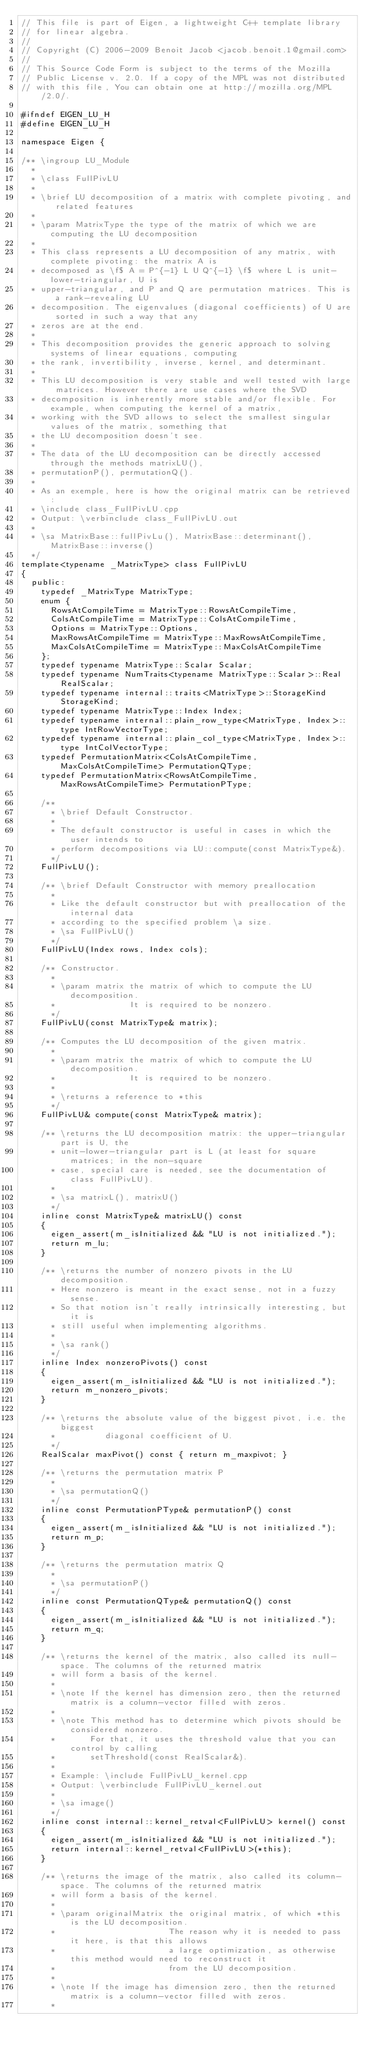<code> <loc_0><loc_0><loc_500><loc_500><_C_>// This file is part of Eigen, a lightweight C++ template library
// for linear algebra.
//
// Copyright (C) 2006-2009 Benoit Jacob <jacob.benoit.1@gmail.com>
//
// This Source Code Form is subject to the terms of the Mozilla
// Public License v. 2.0. If a copy of the MPL was not distributed
// with this file, You can obtain one at http://mozilla.org/MPL/2.0/.

#ifndef EIGEN_LU_H
#define EIGEN_LU_H

namespace Eigen { 

/** \ingroup LU_Module
  *
  * \class FullPivLU
  *
  * \brief LU decomposition of a matrix with complete pivoting, and related features
  *
  * \param MatrixType the type of the matrix of which we are computing the LU decomposition
  *
  * This class represents a LU decomposition of any matrix, with complete pivoting: the matrix A is
  * decomposed as \f$ A = P^{-1} L U Q^{-1} \f$ where L is unit-lower-triangular, U is
  * upper-triangular, and P and Q are permutation matrices. This is a rank-revealing LU
  * decomposition. The eigenvalues (diagonal coefficients) of U are sorted in such a way that any
  * zeros are at the end.
  *
  * This decomposition provides the generic approach to solving systems of linear equations, computing
  * the rank, invertibility, inverse, kernel, and determinant.
  *
  * This LU decomposition is very stable and well tested with large matrices. However there are use cases where the SVD
  * decomposition is inherently more stable and/or flexible. For example, when computing the kernel of a matrix,
  * working with the SVD allows to select the smallest singular values of the matrix, something that
  * the LU decomposition doesn't see.
  *
  * The data of the LU decomposition can be directly accessed through the methods matrixLU(),
  * permutationP(), permutationQ().
  *
  * As an exemple, here is how the original matrix can be retrieved:
  * \include class_FullPivLU.cpp
  * Output: \verbinclude class_FullPivLU.out
  *
  * \sa MatrixBase::fullPivLu(), MatrixBase::determinant(), MatrixBase::inverse()
  */
template<typename _MatrixType> class FullPivLU
{
  public:
    typedef _MatrixType MatrixType;
    enum {
      RowsAtCompileTime = MatrixType::RowsAtCompileTime,
      ColsAtCompileTime = MatrixType::ColsAtCompileTime,
      Options = MatrixType::Options,
      MaxRowsAtCompileTime = MatrixType::MaxRowsAtCompileTime,
      MaxColsAtCompileTime = MatrixType::MaxColsAtCompileTime
    };
    typedef typename MatrixType::Scalar Scalar;
    typedef typename NumTraits<typename MatrixType::Scalar>::Real RealScalar;
    typedef typename internal::traits<MatrixType>::StorageKind StorageKind;
    typedef typename MatrixType::Index Index;
    typedef typename internal::plain_row_type<MatrixType, Index>::type IntRowVectorType;
    typedef typename internal::plain_col_type<MatrixType, Index>::type IntColVectorType;
    typedef PermutationMatrix<ColsAtCompileTime, MaxColsAtCompileTime> PermutationQType;
    typedef PermutationMatrix<RowsAtCompileTime, MaxRowsAtCompileTime> PermutationPType;

    /**
      * \brief Default Constructor.
      *
      * The default constructor is useful in cases in which the user intends to
      * perform decompositions via LU::compute(const MatrixType&).
      */
    FullPivLU();

    /** \brief Default Constructor with memory preallocation
      *
      * Like the default constructor but with preallocation of the internal data
      * according to the specified problem \a size.
      * \sa FullPivLU()
      */
    FullPivLU(Index rows, Index cols);

    /** Constructor.
      *
      * \param matrix the matrix of which to compute the LU decomposition.
      *               It is required to be nonzero.
      */
    FullPivLU(const MatrixType& matrix);

    /** Computes the LU decomposition of the given matrix.
      *
      * \param matrix the matrix of which to compute the LU decomposition.
      *               It is required to be nonzero.
      *
      * \returns a reference to *this
      */
    FullPivLU& compute(const MatrixType& matrix);

    /** \returns the LU decomposition matrix: the upper-triangular part is U, the
      * unit-lower-triangular part is L (at least for square matrices; in the non-square
      * case, special care is needed, see the documentation of class FullPivLU).
      *
      * \sa matrixL(), matrixU()
      */
    inline const MatrixType& matrixLU() const
    {
      eigen_assert(m_isInitialized && "LU is not initialized.");
      return m_lu;
    }

    /** \returns the number of nonzero pivots in the LU decomposition.
      * Here nonzero is meant in the exact sense, not in a fuzzy sense.
      * So that notion isn't really intrinsically interesting, but it is
      * still useful when implementing algorithms.
      *
      * \sa rank()
      */
    inline Index nonzeroPivots() const
    {
      eigen_assert(m_isInitialized && "LU is not initialized.");
      return m_nonzero_pivots;
    }

    /** \returns the absolute value of the biggest pivot, i.e. the biggest
      *          diagonal coefficient of U.
      */
    RealScalar maxPivot() const { return m_maxpivot; }

    /** \returns the permutation matrix P
      *
      * \sa permutationQ()
      */
    inline const PermutationPType& permutationP() const
    {
      eigen_assert(m_isInitialized && "LU is not initialized.");
      return m_p;
    }

    /** \returns the permutation matrix Q
      *
      * \sa permutationP()
      */
    inline const PermutationQType& permutationQ() const
    {
      eigen_assert(m_isInitialized && "LU is not initialized.");
      return m_q;
    }

    /** \returns the kernel of the matrix, also called its null-space. The columns of the returned matrix
      * will form a basis of the kernel.
      *
      * \note If the kernel has dimension zero, then the returned matrix is a column-vector filled with zeros.
      *
      * \note This method has to determine which pivots should be considered nonzero.
      *       For that, it uses the threshold value that you can control by calling
      *       setThreshold(const RealScalar&).
      *
      * Example: \include FullPivLU_kernel.cpp
      * Output: \verbinclude FullPivLU_kernel.out
      *
      * \sa image()
      */
    inline const internal::kernel_retval<FullPivLU> kernel() const
    {
      eigen_assert(m_isInitialized && "LU is not initialized.");
      return internal::kernel_retval<FullPivLU>(*this);
    }

    /** \returns the image of the matrix, also called its column-space. The columns of the returned matrix
      * will form a basis of the kernel.
      *
      * \param originalMatrix the original matrix, of which *this is the LU decomposition.
      *                       The reason why it is needed to pass it here, is that this allows
      *                       a large optimization, as otherwise this method would need to reconstruct it
      *                       from the LU decomposition.
      *
      * \note If the image has dimension zero, then the returned matrix is a column-vector filled with zeros.
      *</code> 